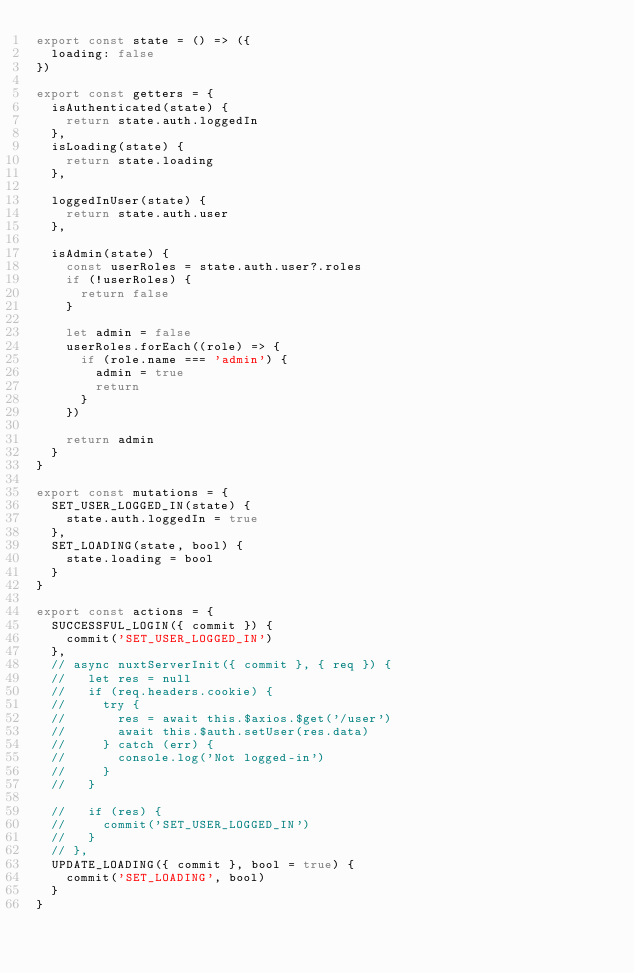<code> <loc_0><loc_0><loc_500><loc_500><_JavaScript_>export const state = () => ({
  loading: false
})

export const getters = {
  isAuthenticated(state) {
    return state.auth.loggedIn
  },
  isLoading(state) {
    return state.loading
  },

  loggedInUser(state) {
    return state.auth.user
  },

  isAdmin(state) {
    const userRoles = state.auth.user?.roles
    if (!userRoles) {
      return false
    }

    let admin = false
    userRoles.forEach((role) => {
      if (role.name === 'admin') {
        admin = true
        return
      }
    })

    return admin
  }
}

export const mutations = {
  SET_USER_LOGGED_IN(state) {
    state.auth.loggedIn = true
  },
  SET_LOADING(state, bool) {
    state.loading = bool
  }
}

export const actions = {
  SUCCESSFUL_LOGIN({ commit }) {
    commit('SET_USER_LOGGED_IN')
  },
  // async nuxtServerInit({ commit }, { req }) {
  //   let res = null
  //   if (req.headers.cookie) {
  //     try {
  //       res = await this.$axios.$get('/user')
  //       await this.$auth.setUser(res.data)
  //     } catch (err) {
  //       console.log('Not logged-in')
  //     }
  //   }

  //   if (res) {
  //     commit('SET_USER_LOGGED_IN')
  //   }
  // },
  UPDATE_LOADING({ commit }, bool = true) {
    commit('SET_LOADING', bool)
  }
}
</code> 